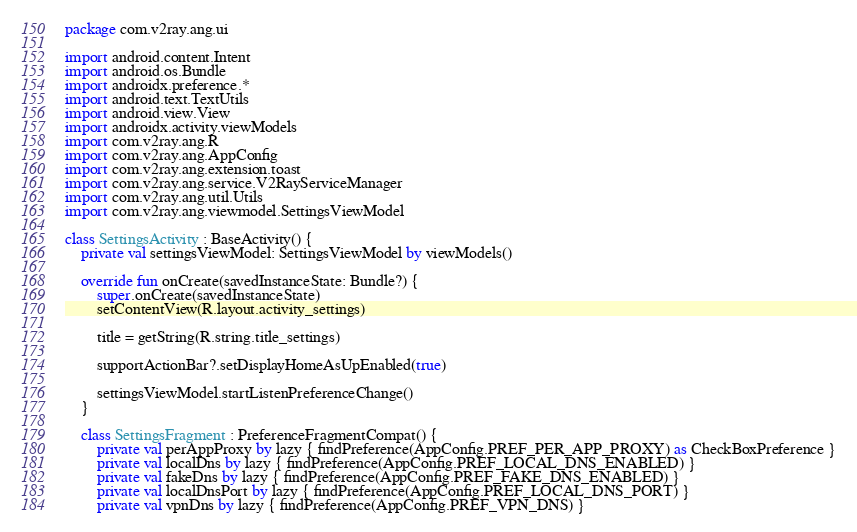Convert code to text. <code><loc_0><loc_0><loc_500><loc_500><_Kotlin_>package com.v2ray.ang.ui

import android.content.Intent
import android.os.Bundle
import androidx.preference.*
import android.text.TextUtils
import android.view.View
import androidx.activity.viewModels
import com.v2ray.ang.R
import com.v2ray.ang.AppConfig
import com.v2ray.ang.extension.toast
import com.v2ray.ang.service.V2RayServiceManager
import com.v2ray.ang.util.Utils
import com.v2ray.ang.viewmodel.SettingsViewModel

class SettingsActivity : BaseActivity() {
    private val settingsViewModel: SettingsViewModel by viewModels()

    override fun onCreate(savedInstanceState: Bundle?) {
        super.onCreate(savedInstanceState)
        setContentView(R.layout.activity_settings)

        title = getString(R.string.title_settings)

        supportActionBar?.setDisplayHomeAsUpEnabled(true)

        settingsViewModel.startListenPreferenceChange()
    }

    class SettingsFragment : PreferenceFragmentCompat() {
        private val perAppProxy by lazy { findPreference(AppConfig.PREF_PER_APP_PROXY) as CheckBoxPreference }
        private val localDns by lazy { findPreference(AppConfig.PREF_LOCAL_DNS_ENABLED) }
        private val fakeDns by lazy { findPreference(AppConfig.PREF_FAKE_DNS_ENABLED) }
        private val localDnsPort by lazy { findPreference(AppConfig.PREF_LOCAL_DNS_PORT) }
        private val vpnDns by lazy { findPreference(AppConfig.PREF_VPN_DNS) }</code> 